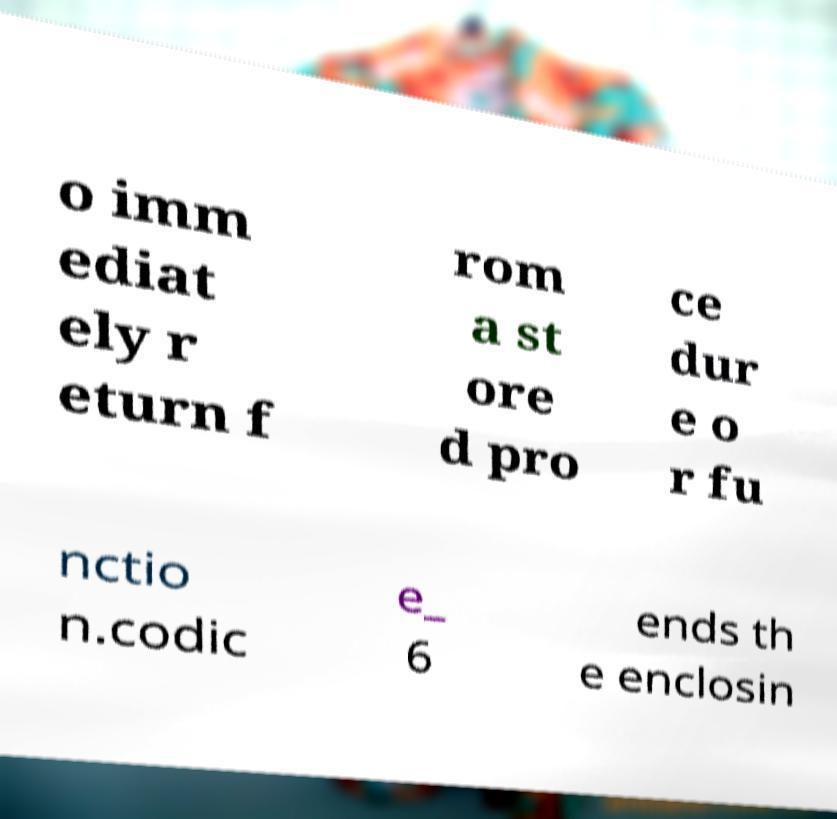Can you accurately transcribe the text from the provided image for me? o imm ediat ely r eturn f rom a st ore d pro ce dur e o r fu nctio n.codic e_ 6 ends th e enclosin 